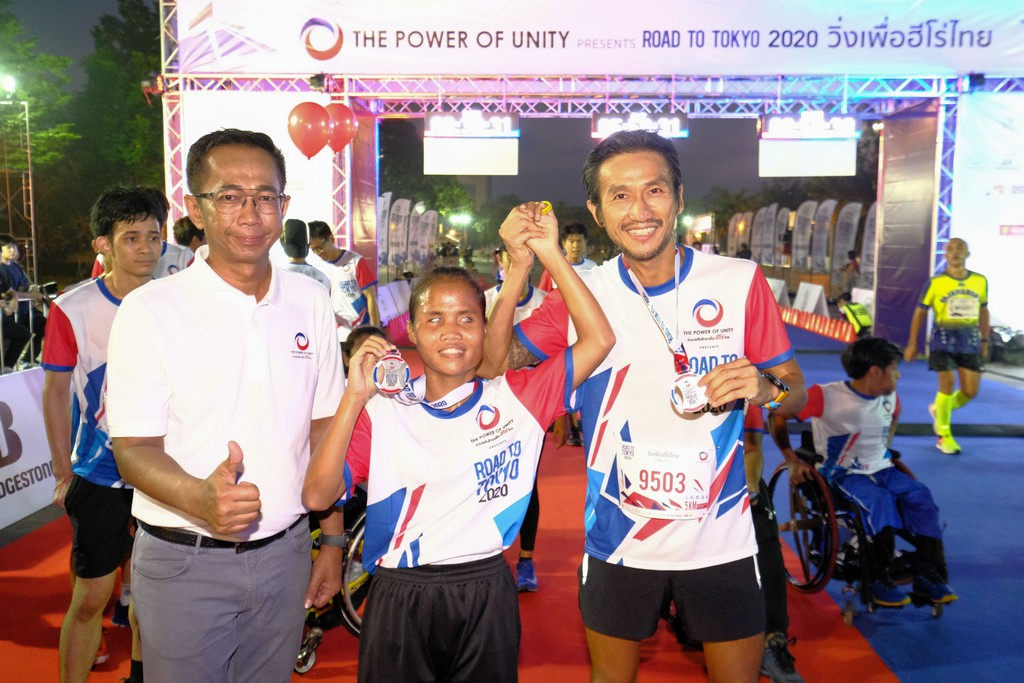Can you elaborate on the significance of the medals shown in the image? The medals worn by the participants in the image are symbolic of achievement and recognition. In the context of a pre-Olympic event like this, the medals suggest the completion and commendation of the participants' efforts in a race or challenge leading up to the Olympics. They serve not only as personal tokens of accomplishment but also as tools to motivate and inspire both the recipients and onlookers. These medals are a tangible representation of the hard work, discipline, and sportsmanship that the Olympics aim to foster among athletes worldwide. 